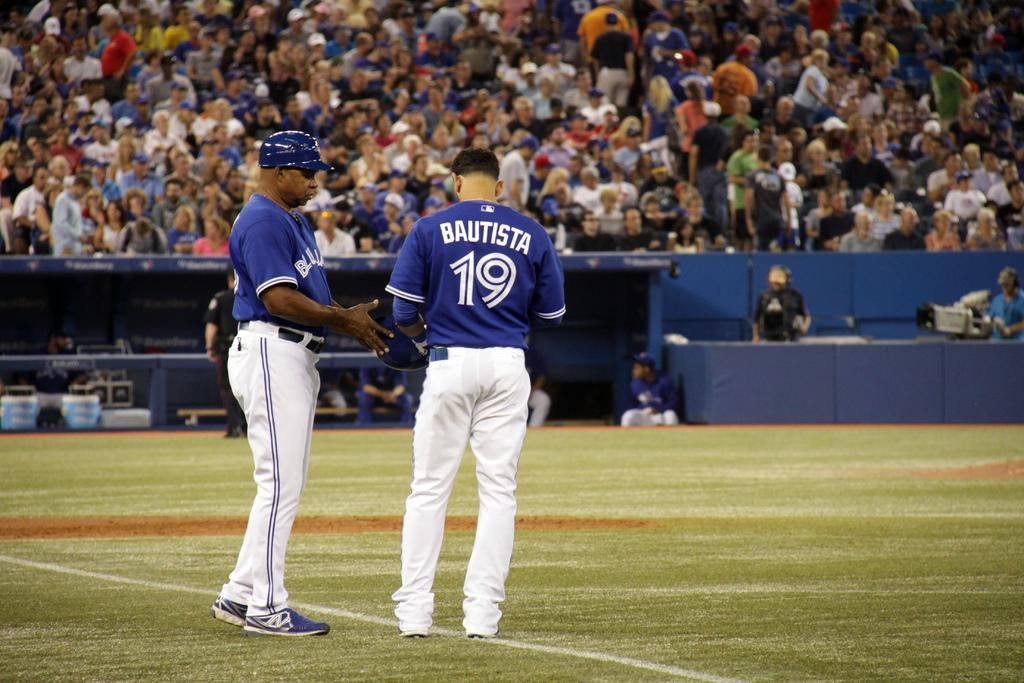Provide a one-sentence caption for the provided image. Two baseball players wearing blue and one called Bautista and wearing the number 19 talk on the park in front of a large crowd. 